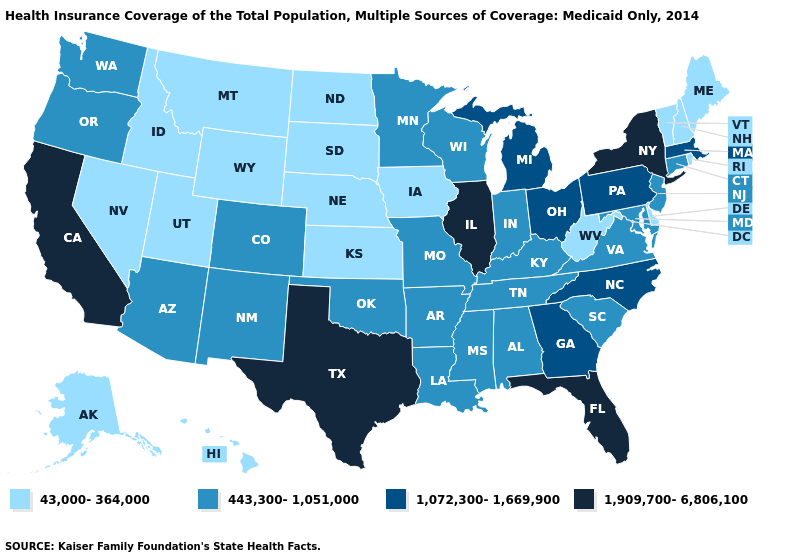Name the states that have a value in the range 43,000-364,000?
Short answer required. Alaska, Delaware, Hawaii, Idaho, Iowa, Kansas, Maine, Montana, Nebraska, Nevada, New Hampshire, North Dakota, Rhode Island, South Dakota, Utah, Vermont, West Virginia, Wyoming. Does West Virginia have the lowest value in the South?
Give a very brief answer. Yes. Does New Hampshire have a lower value than Rhode Island?
Concise answer only. No. Does Ohio have the same value as Minnesota?
Short answer required. No. What is the lowest value in states that border Rhode Island?
Keep it brief. 443,300-1,051,000. What is the lowest value in states that border Texas?
Quick response, please. 443,300-1,051,000. Among the states that border Minnesota , does Iowa have the lowest value?
Concise answer only. Yes. Among the states that border Texas , which have the highest value?
Keep it brief. Arkansas, Louisiana, New Mexico, Oklahoma. What is the lowest value in states that border Michigan?
Quick response, please. 443,300-1,051,000. What is the value of Alaska?
Write a very short answer. 43,000-364,000. Which states have the lowest value in the West?
Quick response, please. Alaska, Hawaii, Idaho, Montana, Nevada, Utah, Wyoming. What is the highest value in the MidWest ?
Give a very brief answer. 1,909,700-6,806,100. Among the states that border Tennessee , which have the lowest value?
Quick response, please. Alabama, Arkansas, Kentucky, Mississippi, Missouri, Virginia. What is the value of Iowa?
Quick response, please. 43,000-364,000. Does Missouri have the highest value in the USA?
Quick response, please. No. 